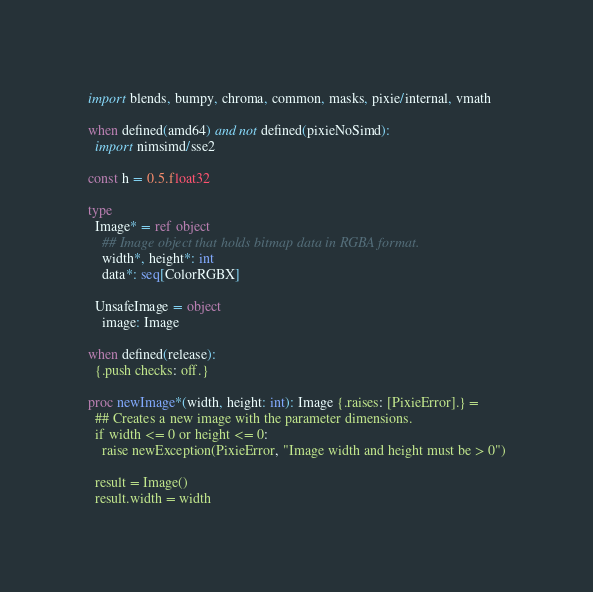Convert code to text. <code><loc_0><loc_0><loc_500><loc_500><_Nim_>import blends, bumpy, chroma, common, masks, pixie/internal, vmath

when defined(amd64) and not defined(pixieNoSimd):
  import nimsimd/sse2

const h = 0.5.float32

type
  Image* = ref object
    ## Image object that holds bitmap data in RGBA format.
    width*, height*: int
    data*: seq[ColorRGBX]

  UnsafeImage = object
    image: Image

when defined(release):
  {.push checks: off.}

proc newImage*(width, height: int): Image {.raises: [PixieError].} =
  ## Creates a new image with the parameter dimensions.
  if width <= 0 or height <= 0:
    raise newException(PixieError, "Image width and height must be > 0")

  result = Image()
  result.width = width</code> 